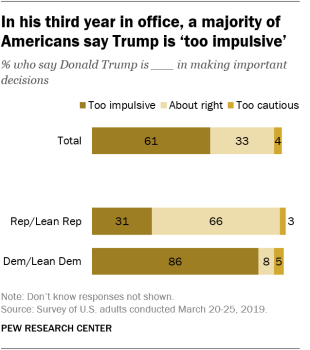Highlight a few significant elements in this photo. According to a recent survey, a small percentage of Americans, 0.61%, believe that Donald Trump is too impulsive in making important decisions. The average of "Too impulsive" bars is greater than the median of "About right" bars. 